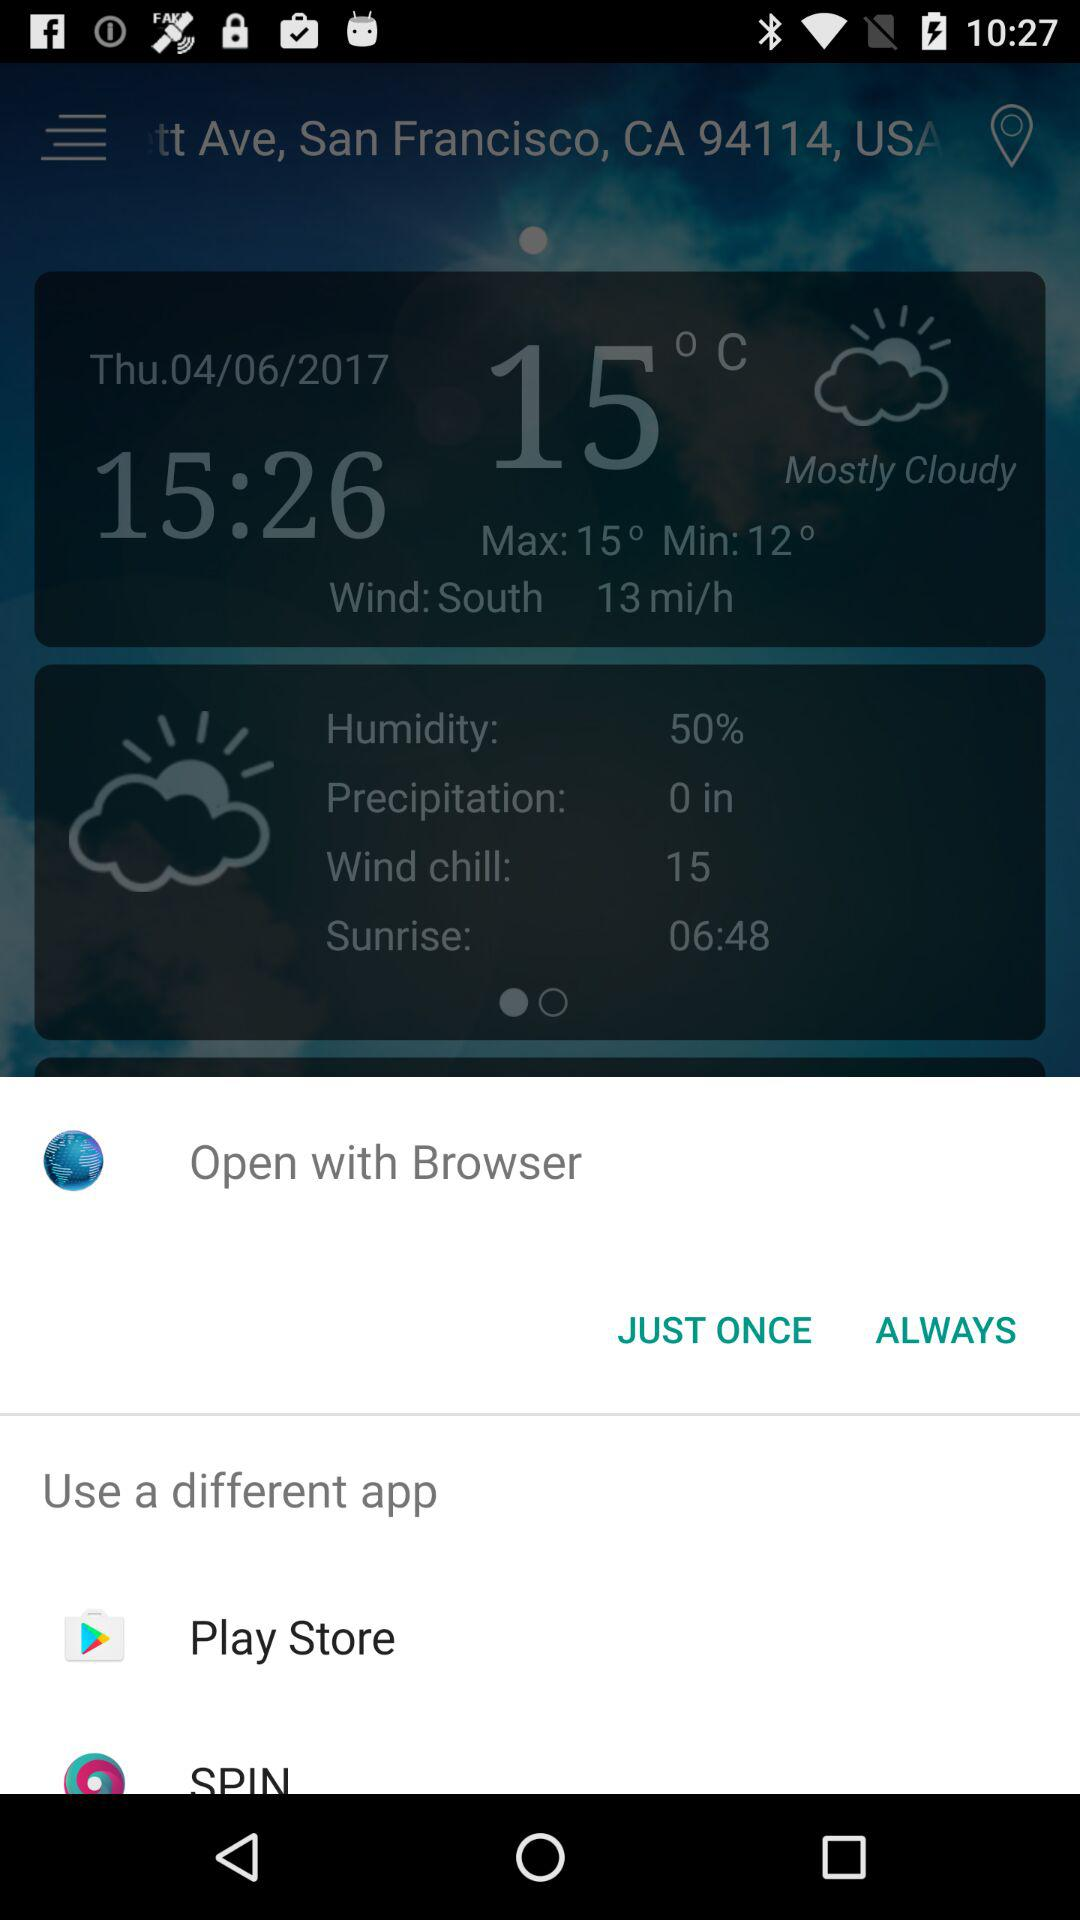What is the humidity percentage?
Answer the question using a single word or phrase. 50% 